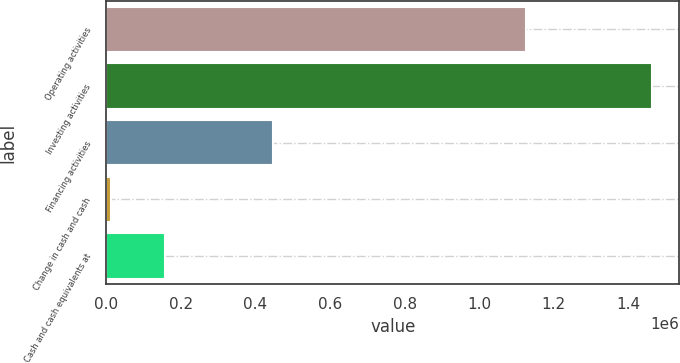Convert chart to OTSL. <chart><loc_0><loc_0><loc_500><loc_500><bar_chart><fcel>Operating activities<fcel>Investing activities<fcel>Financing activities<fcel>Change in cash and cash<fcel>Cash and cash equivalents at<nl><fcel>1.12466e+06<fcel>1.46357e+06<fcel>447916<fcel>12638<fcel>157731<nl></chart> 